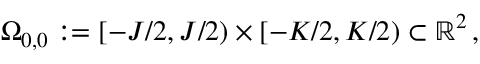<formula> <loc_0><loc_0><loc_500><loc_500>\Omega _ { 0 , 0 } \colon = [ - J / 2 , J / 2 ) \times [ - K / 2 , K / 2 ) \subset \mathbb { R } ^ { 2 } \, ,</formula> 